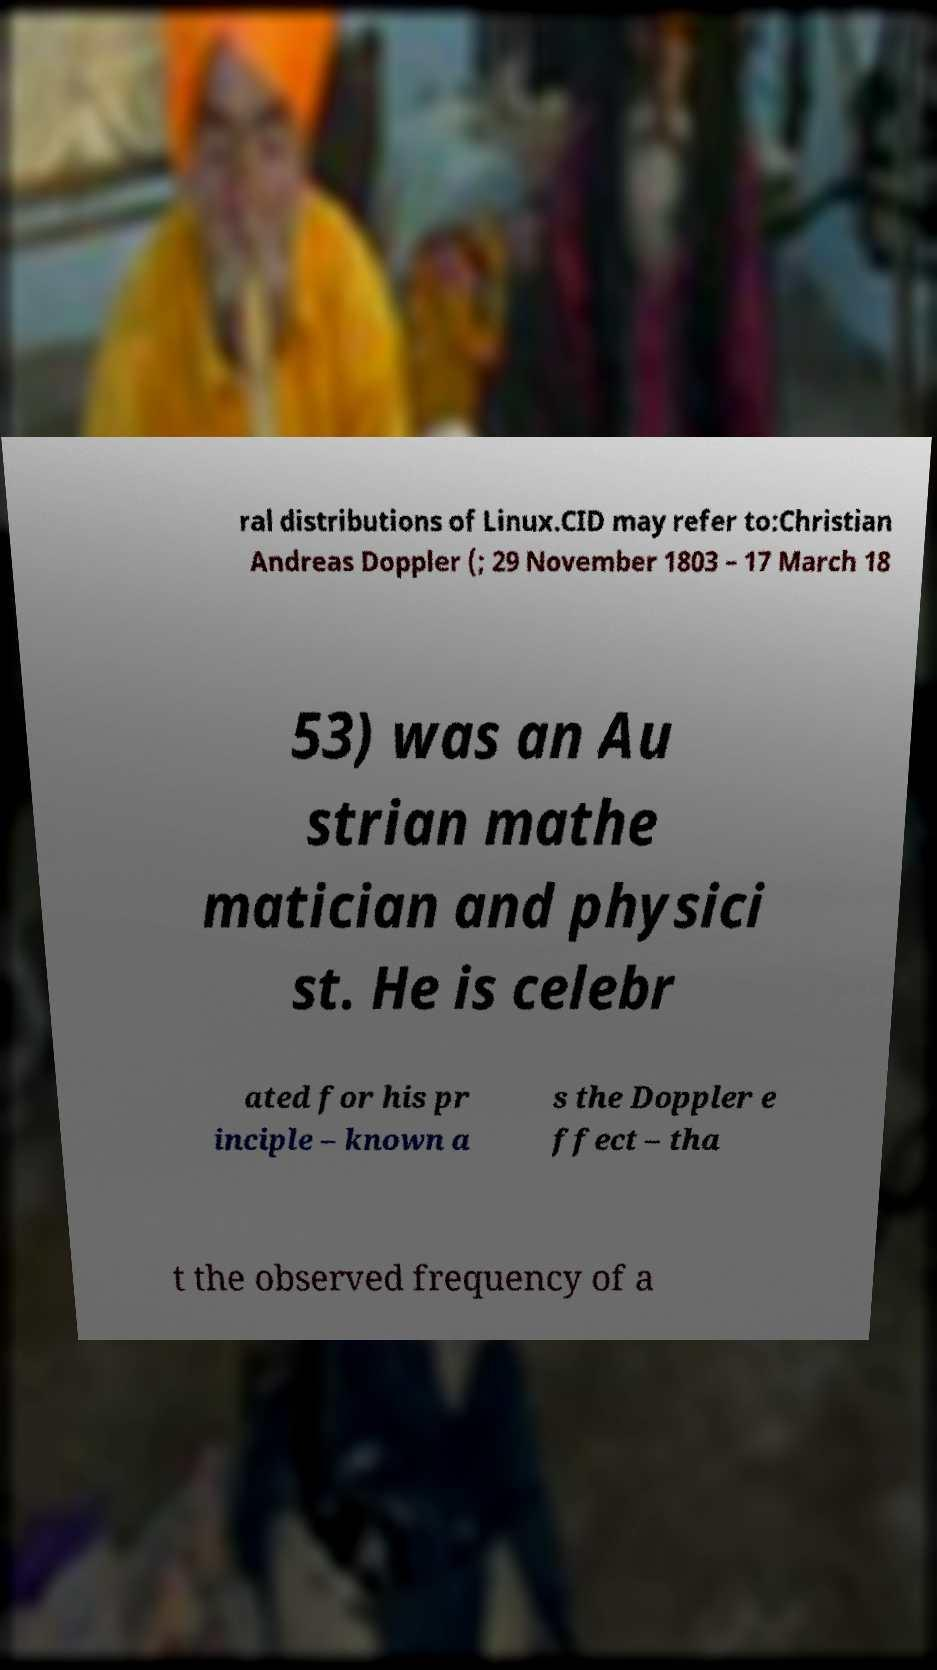What messages or text are displayed in this image? I need them in a readable, typed format. ral distributions of Linux.CID may refer to:Christian Andreas Doppler (; 29 November 1803 – 17 March 18 53) was an Au strian mathe matician and physici st. He is celebr ated for his pr inciple – known a s the Doppler e ffect – tha t the observed frequency of a 